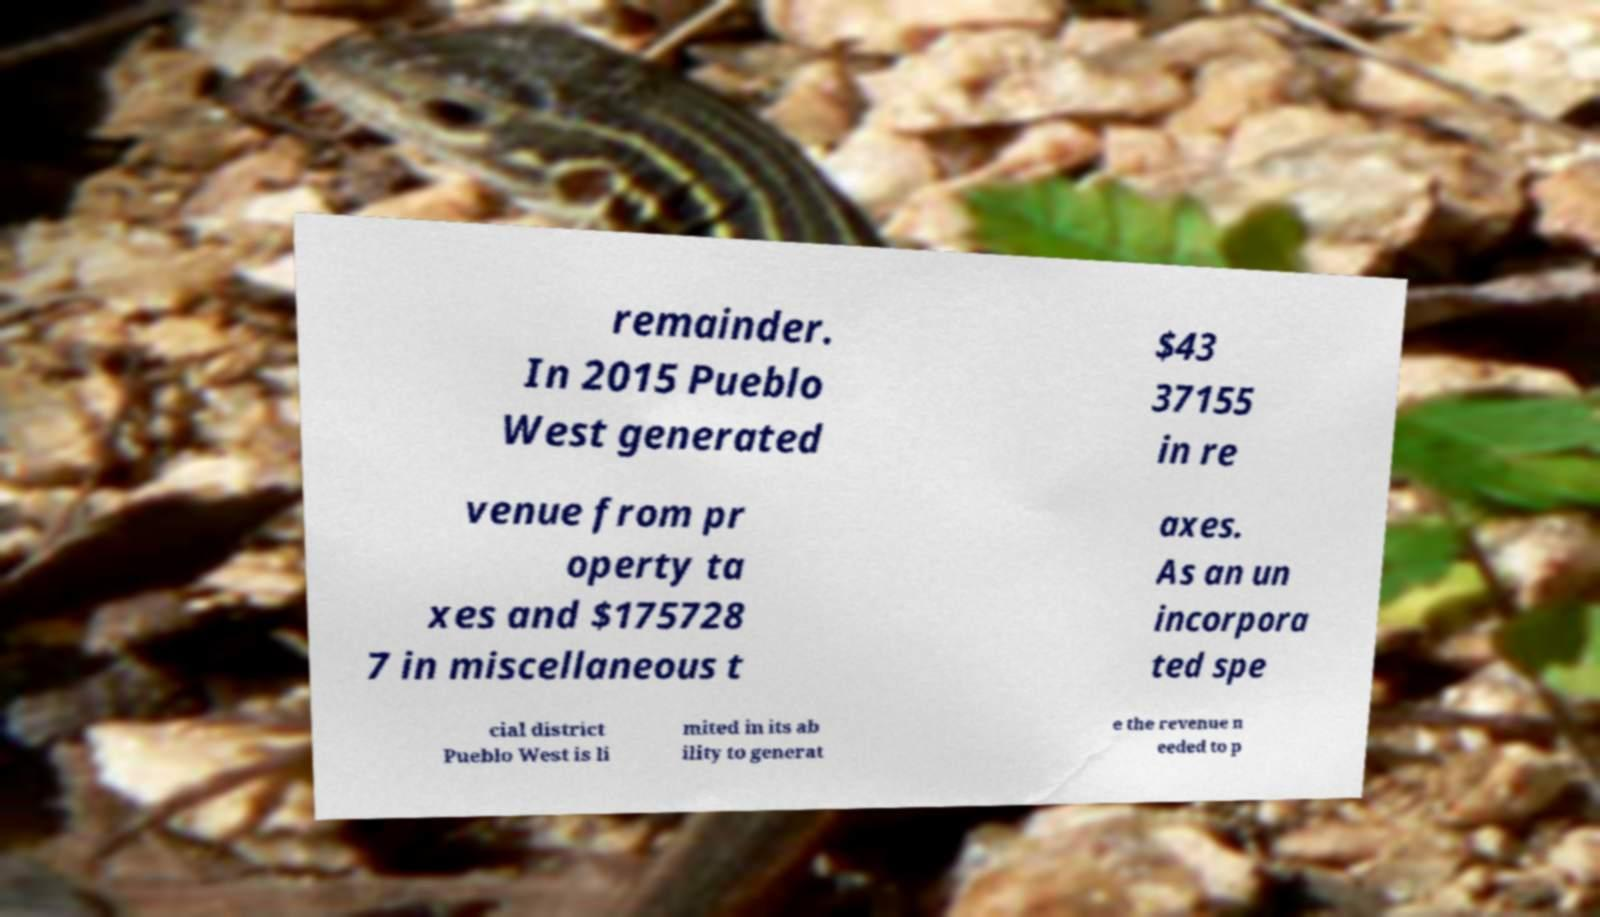What messages or text are displayed in this image? I need them in a readable, typed format. remainder. In 2015 Pueblo West generated $43 37155 in re venue from pr operty ta xes and $175728 7 in miscellaneous t axes. As an un incorpora ted spe cial district Pueblo West is li mited in its ab ility to generat e the revenue n eeded to p 